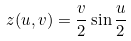<formula> <loc_0><loc_0><loc_500><loc_500>z ( u , v ) = { \frac { v } { 2 } } \sin { \frac { u } { 2 } }</formula> 